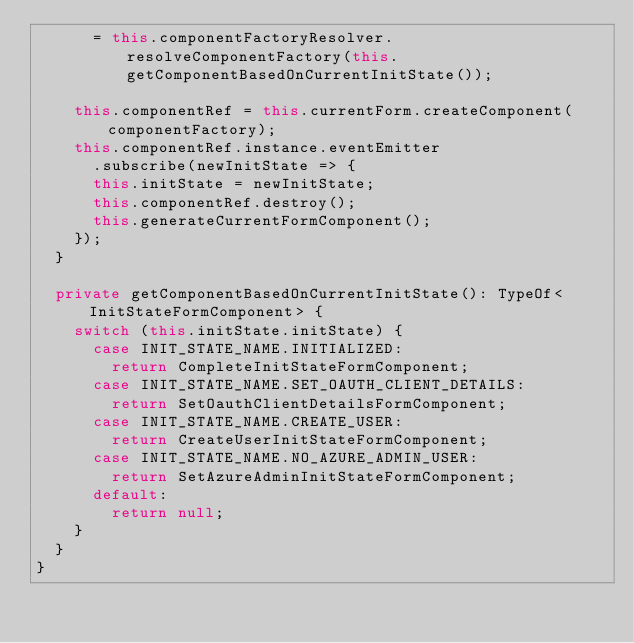<code> <loc_0><loc_0><loc_500><loc_500><_TypeScript_>      = this.componentFactoryResolver.resolveComponentFactory(this.getComponentBasedOnCurrentInitState());

    this.componentRef = this.currentForm.createComponent(componentFactory);
    this.componentRef.instance.eventEmitter
      .subscribe(newInitState => {
      this.initState = newInitState;
      this.componentRef.destroy();
      this.generateCurrentFormComponent();
    });
  }

  private getComponentBasedOnCurrentInitState(): TypeOf<InitStateFormComponent> {
    switch (this.initState.initState) {
      case INIT_STATE_NAME.INITIALIZED:
        return CompleteInitStateFormComponent;
      case INIT_STATE_NAME.SET_OAUTH_CLIENT_DETAILS:
        return SetOauthClientDetailsFormComponent;
      case INIT_STATE_NAME.CREATE_USER:
        return CreateUserInitStateFormComponent;
      case INIT_STATE_NAME.NO_AZURE_ADMIN_USER:
        return SetAzureAdminInitStateFormComponent;
      default:
        return null;
    }
  }
}
</code> 